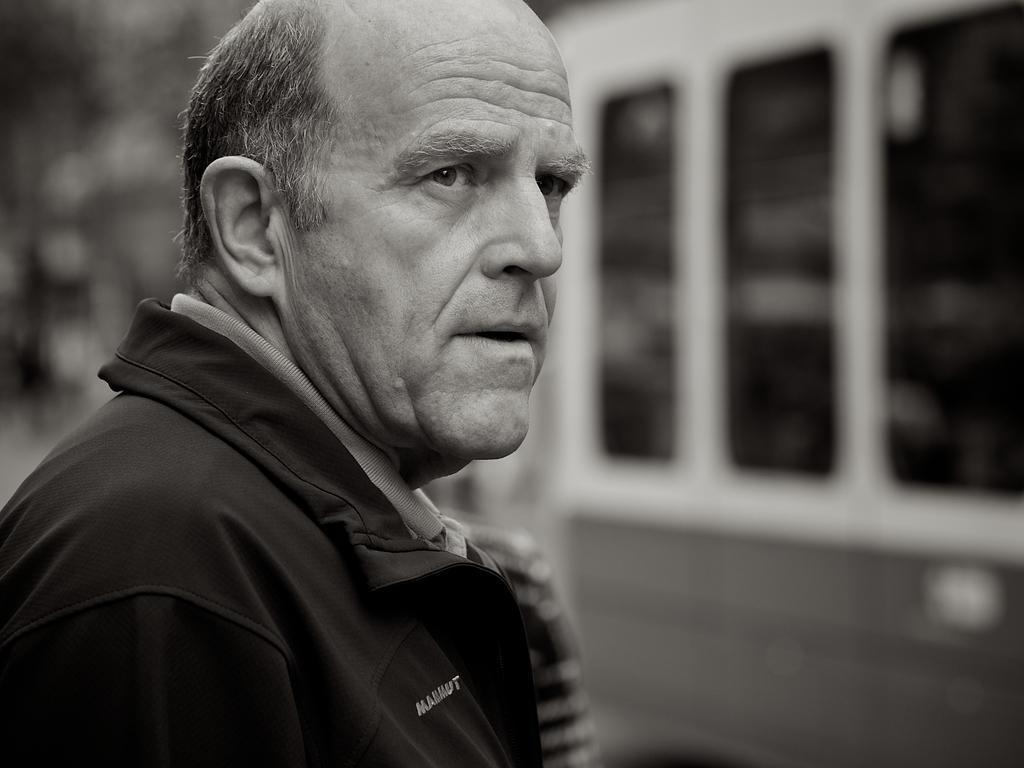In one or two sentences, can you explain what this image depicts? In this image we can see a man standing. He is wearing a jacket. On the right there is a vehicle. 